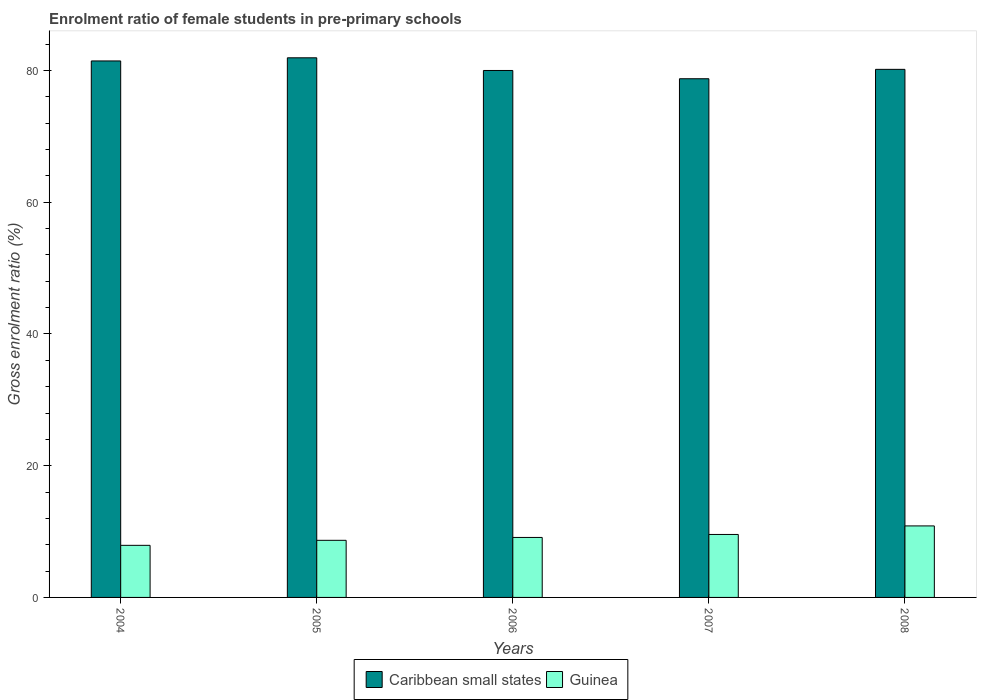How many different coloured bars are there?
Ensure brevity in your answer.  2. Are the number of bars per tick equal to the number of legend labels?
Provide a succinct answer. Yes. How many bars are there on the 3rd tick from the left?
Your answer should be compact. 2. How many bars are there on the 5th tick from the right?
Your answer should be very brief. 2. What is the enrolment ratio of female students in pre-primary schools in Caribbean small states in 2005?
Offer a terse response. 81.93. Across all years, what is the maximum enrolment ratio of female students in pre-primary schools in Caribbean small states?
Give a very brief answer. 81.93. Across all years, what is the minimum enrolment ratio of female students in pre-primary schools in Guinea?
Ensure brevity in your answer.  7.91. In which year was the enrolment ratio of female students in pre-primary schools in Guinea maximum?
Give a very brief answer. 2008. What is the total enrolment ratio of female students in pre-primary schools in Guinea in the graph?
Make the answer very short. 46.1. What is the difference between the enrolment ratio of female students in pre-primary schools in Caribbean small states in 2005 and that in 2008?
Provide a short and direct response. 1.75. What is the difference between the enrolment ratio of female students in pre-primary schools in Guinea in 2007 and the enrolment ratio of female students in pre-primary schools in Caribbean small states in 2006?
Offer a terse response. -70.44. What is the average enrolment ratio of female students in pre-primary schools in Caribbean small states per year?
Your answer should be compact. 80.46. In the year 2004, what is the difference between the enrolment ratio of female students in pre-primary schools in Caribbean small states and enrolment ratio of female students in pre-primary schools in Guinea?
Provide a succinct answer. 73.54. In how many years, is the enrolment ratio of female students in pre-primary schools in Caribbean small states greater than 68 %?
Offer a very short reply. 5. What is the ratio of the enrolment ratio of female students in pre-primary schools in Caribbean small states in 2004 to that in 2008?
Offer a terse response. 1.02. Is the enrolment ratio of female students in pre-primary schools in Guinea in 2004 less than that in 2005?
Make the answer very short. Yes. What is the difference between the highest and the second highest enrolment ratio of female students in pre-primary schools in Caribbean small states?
Provide a short and direct response. 0.48. What is the difference between the highest and the lowest enrolment ratio of female students in pre-primary schools in Caribbean small states?
Your answer should be compact. 3.18. In how many years, is the enrolment ratio of female students in pre-primary schools in Caribbean small states greater than the average enrolment ratio of female students in pre-primary schools in Caribbean small states taken over all years?
Provide a short and direct response. 2. What does the 1st bar from the left in 2008 represents?
Offer a very short reply. Caribbean small states. What does the 2nd bar from the right in 2004 represents?
Your answer should be very brief. Caribbean small states. How many years are there in the graph?
Keep it short and to the point. 5. Does the graph contain grids?
Provide a short and direct response. No. Where does the legend appear in the graph?
Offer a terse response. Bottom center. How many legend labels are there?
Ensure brevity in your answer.  2. What is the title of the graph?
Give a very brief answer. Enrolment ratio of female students in pre-primary schools. Does "Sub-Saharan Africa (all income levels)" appear as one of the legend labels in the graph?
Provide a succinct answer. No. What is the label or title of the X-axis?
Provide a succinct answer. Years. What is the Gross enrolment ratio (%) in Caribbean small states in 2004?
Offer a very short reply. 81.45. What is the Gross enrolment ratio (%) in Guinea in 2004?
Offer a terse response. 7.91. What is the Gross enrolment ratio (%) in Caribbean small states in 2005?
Your response must be concise. 81.93. What is the Gross enrolment ratio (%) in Guinea in 2005?
Your answer should be compact. 8.67. What is the Gross enrolment ratio (%) of Caribbean small states in 2006?
Make the answer very short. 80. What is the Gross enrolment ratio (%) in Guinea in 2006?
Your response must be concise. 9.11. What is the Gross enrolment ratio (%) in Caribbean small states in 2007?
Make the answer very short. 78.75. What is the Gross enrolment ratio (%) of Guinea in 2007?
Keep it short and to the point. 9.56. What is the Gross enrolment ratio (%) in Caribbean small states in 2008?
Your answer should be compact. 80.18. What is the Gross enrolment ratio (%) of Guinea in 2008?
Provide a succinct answer. 10.86. Across all years, what is the maximum Gross enrolment ratio (%) of Caribbean small states?
Offer a terse response. 81.93. Across all years, what is the maximum Gross enrolment ratio (%) of Guinea?
Make the answer very short. 10.86. Across all years, what is the minimum Gross enrolment ratio (%) of Caribbean small states?
Ensure brevity in your answer.  78.75. Across all years, what is the minimum Gross enrolment ratio (%) of Guinea?
Provide a short and direct response. 7.91. What is the total Gross enrolment ratio (%) in Caribbean small states in the graph?
Provide a short and direct response. 402.31. What is the total Gross enrolment ratio (%) of Guinea in the graph?
Ensure brevity in your answer.  46.1. What is the difference between the Gross enrolment ratio (%) of Caribbean small states in 2004 and that in 2005?
Keep it short and to the point. -0.48. What is the difference between the Gross enrolment ratio (%) in Guinea in 2004 and that in 2005?
Offer a very short reply. -0.76. What is the difference between the Gross enrolment ratio (%) of Caribbean small states in 2004 and that in 2006?
Your answer should be very brief. 1.45. What is the difference between the Gross enrolment ratio (%) in Guinea in 2004 and that in 2006?
Your answer should be very brief. -1.2. What is the difference between the Gross enrolment ratio (%) in Caribbean small states in 2004 and that in 2007?
Keep it short and to the point. 2.7. What is the difference between the Gross enrolment ratio (%) in Guinea in 2004 and that in 2007?
Keep it short and to the point. -1.65. What is the difference between the Gross enrolment ratio (%) of Caribbean small states in 2004 and that in 2008?
Offer a very short reply. 1.28. What is the difference between the Gross enrolment ratio (%) of Guinea in 2004 and that in 2008?
Provide a short and direct response. -2.95. What is the difference between the Gross enrolment ratio (%) of Caribbean small states in 2005 and that in 2006?
Ensure brevity in your answer.  1.92. What is the difference between the Gross enrolment ratio (%) in Guinea in 2005 and that in 2006?
Ensure brevity in your answer.  -0.44. What is the difference between the Gross enrolment ratio (%) of Caribbean small states in 2005 and that in 2007?
Offer a very short reply. 3.18. What is the difference between the Gross enrolment ratio (%) in Guinea in 2005 and that in 2007?
Your answer should be compact. -0.89. What is the difference between the Gross enrolment ratio (%) in Caribbean small states in 2005 and that in 2008?
Offer a terse response. 1.75. What is the difference between the Gross enrolment ratio (%) in Guinea in 2005 and that in 2008?
Your answer should be compact. -2.19. What is the difference between the Gross enrolment ratio (%) of Caribbean small states in 2006 and that in 2007?
Provide a short and direct response. 1.25. What is the difference between the Gross enrolment ratio (%) of Guinea in 2006 and that in 2007?
Offer a very short reply. -0.45. What is the difference between the Gross enrolment ratio (%) of Caribbean small states in 2006 and that in 2008?
Your response must be concise. -0.17. What is the difference between the Gross enrolment ratio (%) of Guinea in 2006 and that in 2008?
Offer a very short reply. -1.75. What is the difference between the Gross enrolment ratio (%) of Caribbean small states in 2007 and that in 2008?
Provide a short and direct response. -1.43. What is the difference between the Gross enrolment ratio (%) of Guinea in 2007 and that in 2008?
Your answer should be very brief. -1.3. What is the difference between the Gross enrolment ratio (%) in Caribbean small states in 2004 and the Gross enrolment ratio (%) in Guinea in 2005?
Provide a succinct answer. 72.78. What is the difference between the Gross enrolment ratio (%) of Caribbean small states in 2004 and the Gross enrolment ratio (%) of Guinea in 2006?
Provide a short and direct response. 72.34. What is the difference between the Gross enrolment ratio (%) of Caribbean small states in 2004 and the Gross enrolment ratio (%) of Guinea in 2007?
Your response must be concise. 71.89. What is the difference between the Gross enrolment ratio (%) of Caribbean small states in 2004 and the Gross enrolment ratio (%) of Guinea in 2008?
Provide a succinct answer. 70.59. What is the difference between the Gross enrolment ratio (%) of Caribbean small states in 2005 and the Gross enrolment ratio (%) of Guinea in 2006?
Offer a very short reply. 72.82. What is the difference between the Gross enrolment ratio (%) of Caribbean small states in 2005 and the Gross enrolment ratio (%) of Guinea in 2007?
Offer a very short reply. 72.37. What is the difference between the Gross enrolment ratio (%) in Caribbean small states in 2005 and the Gross enrolment ratio (%) in Guinea in 2008?
Your answer should be compact. 71.07. What is the difference between the Gross enrolment ratio (%) in Caribbean small states in 2006 and the Gross enrolment ratio (%) in Guinea in 2007?
Your answer should be very brief. 70.44. What is the difference between the Gross enrolment ratio (%) of Caribbean small states in 2006 and the Gross enrolment ratio (%) of Guinea in 2008?
Provide a short and direct response. 69.15. What is the difference between the Gross enrolment ratio (%) in Caribbean small states in 2007 and the Gross enrolment ratio (%) in Guinea in 2008?
Keep it short and to the point. 67.89. What is the average Gross enrolment ratio (%) of Caribbean small states per year?
Offer a terse response. 80.46. What is the average Gross enrolment ratio (%) in Guinea per year?
Provide a succinct answer. 9.22. In the year 2004, what is the difference between the Gross enrolment ratio (%) in Caribbean small states and Gross enrolment ratio (%) in Guinea?
Your response must be concise. 73.54. In the year 2005, what is the difference between the Gross enrolment ratio (%) of Caribbean small states and Gross enrolment ratio (%) of Guinea?
Ensure brevity in your answer.  73.26. In the year 2006, what is the difference between the Gross enrolment ratio (%) of Caribbean small states and Gross enrolment ratio (%) of Guinea?
Give a very brief answer. 70.9. In the year 2007, what is the difference between the Gross enrolment ratio (%) in Caribbean small states and Gross enrolment ratio (%) in Guinea?
Provide a succinct answer. 69.19. In the year 2008, what is the difference between the Gross enrolment ratio (%) in Caribbean small states and Gross enrolment ratio (%) in Guinea?
Keep it short and to the point. 69.32. What is the ratio of the Gross enrolment ratio (%) in Caribbean small states in 2004 to that in 2005?
Your answer should be compact. 0.99. What is the ratio of the Gross enrolment ratio (%) of Guinea in 2004 to that in 2005?
Give a very brief answer. 0.91. What is the ratio of the Gross enrolment ratio (%) of Caribbean small states in 2004 to that in 2006?
Provide a short and direct response. 1.02. What is the ratio of the Gross enrolment ratio (%) of Guinea in 2004 to that in 2006?
Provide a succinct answer. 0.87. What is the ratio of the Gross enrolment ratio (%) in Caribbean small states in 2004 to that in 2007?
Provide a short and direct response. 1.03. What is the ratio of the Gross enrolment ratio (%) in Guinea in 2004 to that in 2007?
Your response must be concise. 0.83. What is the ratio of the Gross enrolment ratio (%) in Caribbean small states in 2004 to that in 2008?
Ensure brevity in your answer.  1.02. What is the ratio of the Gross enrolment ratio (%) of Guinea in 2004 to that in 2008?
Make the answer very short. 0.73. What is the ratio of the Gross enrolment ratio (%) in Guinea in 2005 to that in 2006?
Provide a succinct answer. 0.95. What is the ratio of the Gross enrolment ratio (%) of Caribbean small states in 2005 to that in 2007?
Provide a succinct answer. 1.04. What is the ratio of the Gross enrolment ratio (%) in Guinea in 2005 to that in 2007?
Provide a succinct answer. 0.91. What is the ratio of the Gross enrolment ratio (%) of Caribbean small states in 2005 to that in 2008?
Give a very brief answer. 1.02. What is the ratio of the Gross enrolment ratio (%) of Guinea in 2005 to that in 2008?
Ensure brevity in your answer.  0.8. What is the ratio of the Gross enrolment ratio (%) in Caribbean small states in 2006 to that in 2007?
Provide a short and direct response. 1.02. What is the ratio of the Gross enrolment ratio (%) of Guinea in 2006 to that in 2007?
Provide a short and direct response. 0.95. What is the ratio of the Gross enrolment ratio (%) in Caribbean small states in 2006 to that in 2008?
Offer a terse response. 1. What is the ratio of the Gross enrolment ratio (%) in Guinea in 2006 to that in 2008?
Provide a short and direct response. 0.84. What is the ratio of the Gross enrolment ratio (%) of Caribbean small states in 2007 to that in 2008?
Offer a very short reply. 0.98. What is the ratio of the Gross enrolment ratio (%) in Guinea in 2007 to that in 2008?
Make the answer very short. 0.88. What is the difference between the highest and the second highest Gross enrolment ratio (%) of Caribbean small states?
Your answer should be compact. 0.48. What is the difference between the highest and the second highest Gross enrolment ratio (%) of Guinea?
Your answer should be very brief. 1.3. What is the difference between the highest and the lowest Gross enrolment ratio (%) in Caribbean small states?
Ensure brevity in your answer.  3.18. What is the difference between the highest and the lowest Gross enrolment ratio (%) in Guinea?
Ensure brevity in your answer.  2.95. 